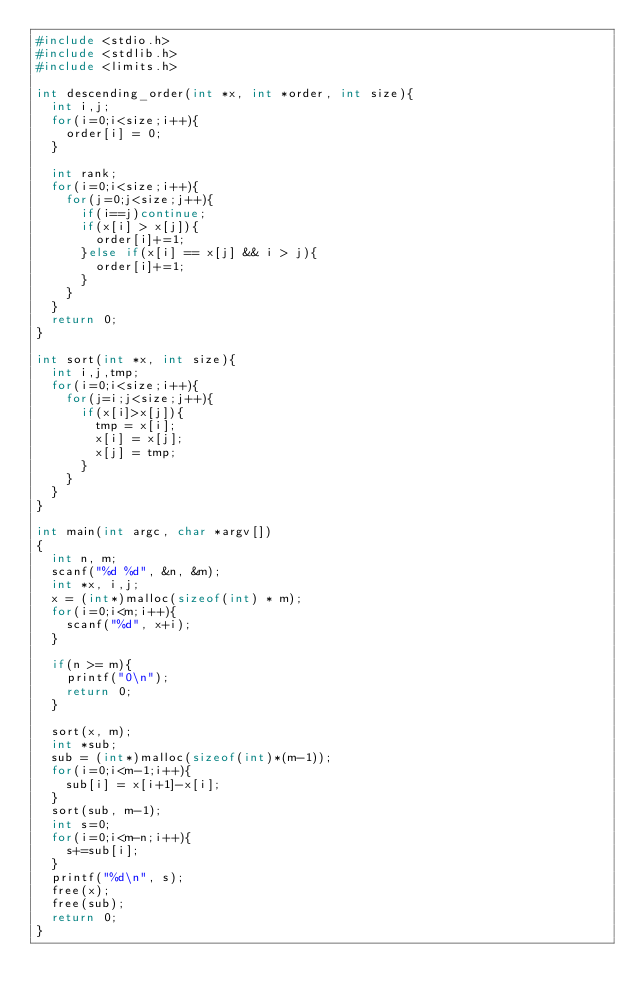<code> <loc_0><loc_0><loc_500><loc_500><_C_>#include <stdio.h>
#include <stdlib.h>
#include <limits.h>

int descending_order(int *x, int *order, int size){
  int i,j;
  for(i=0;i<size;i++){
    order[i] = 0;
  }

  int rank;
  for(i=0;i<size;i++){
    for(j=0;j<size;j++){
      if(i==j)continue;
      if(x[i] > x[j]){
        order[i]+=1;
      }else if(x[i] == x[j] && i > j){
        order[i]+=1;
      }
    }
  }
  return 0;
}

int sort(int *x, int size){
  int i,j,tmp;
  for(i=0;i<size;i++){
    for(j=i;j<size;j++){
      if(x[i]>x[j]){
        tmp = x[i];
        x[i] = x[j];
        x[j] = tmp;
      }
    }
  }
}

int main(int argc, char *argv[])
{
  int n, m;
  scanf("%d %d", &n, &m);
  int *x, i,j;
  x = (int*)malloc(sizeof(int) * m);
  for(i=0;i<m;i++){
    scanf("%d", x+i);
  }

  if(n >= m){
    printf("0\n");
    return 0;
  }

  sort(x, m);
  int *sub;
  sub = (int*)malloc(sizeof(int)*(m-1));
  for(i=0;i<m-1;i++){
    sub[i] = x[i+1]-x[i];
  }
  sort(sub, m-1);
  int s=0;
  for(i=0;i<m-n;i++){
    s+=sub[i];
  }
  printf("%d\n", s);
  free(x);
  free(sub);
  return 0;
}
</code> 